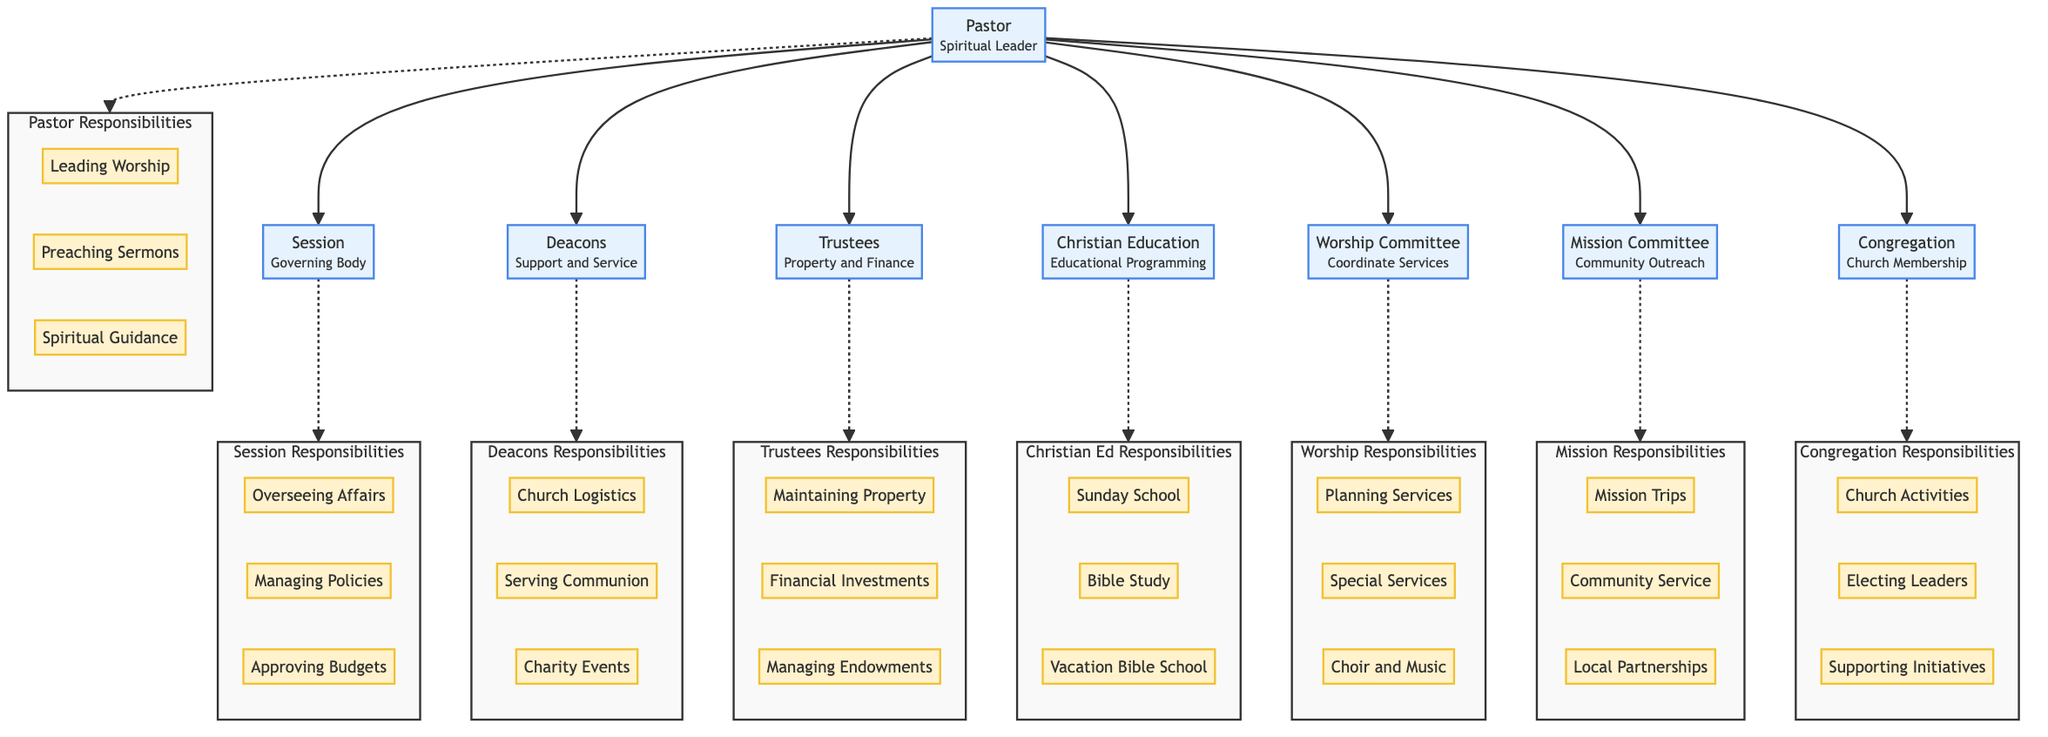What is the role of the Pastor? The Pastor is identified as the "Spiritual Leader" in the diagram. This is presented at the top of the first block, indicating their primary function within the church structure.
Answer: Spiritual Leader How many committees report directly to the Pastor? The diagram shows six nodes branching from the Pastor, which represent the Session, Deacons, Trustees, Christian Education Committee, Worship Committee, Mission Committee, and Congregation. Thus, there are six committees reporting directly.
Answer: 6 What are the responsibilities of the Deacons? The Deacons' responsibilities are listed in the diagram, including "Assisting with Church Logistics," "Serving Communion," and "Organizing Charity Events." These items can be found under the block labeled "Deacons Responsibilities."
Answer: Assisting with Church Logistics, Serving Communion, Organizing Charity Events Which committee is responsible for planning mission trips? The "Mission Committee" is explicitly stated to have the responsibility of "Planning Mission Trips," found in the responsibilities section of that node.
Answer: Mission Committee What is the primary role of the Christian Education Committee? The diagram indicates that the Christian Education Committee holds the role of "Educational Programming." This role is highlighted in the block designated for this committee, making it clear and distinct.
Answer: Educational Programming What are the responsibilities of the Session? The responsibilities assigned to the Session are listed in the diagram: "Overseeing Church Affairs," "Managing Church Policies," and "Approving Budgets." This information is gathered from the responsibilities block associated with the Session.
Answer: Overseeing Church Affairs, Managing Church Policies, Approving Budgets Which group has the responsibility of managing church property? The "Trustees" are designated as the group responsible for "Maintaining Church Property," as depicted in the responsibilities outlined within the Trustees section of the diagram.
Answer: Trustees How does the Congregation contribute to church leadership? The Congregation participates by "Electing Church Leaders," as indicated under the responsibilities section of the Congregation node. This shows their involvement in church governance.
Answer: Electing Church Leaders 